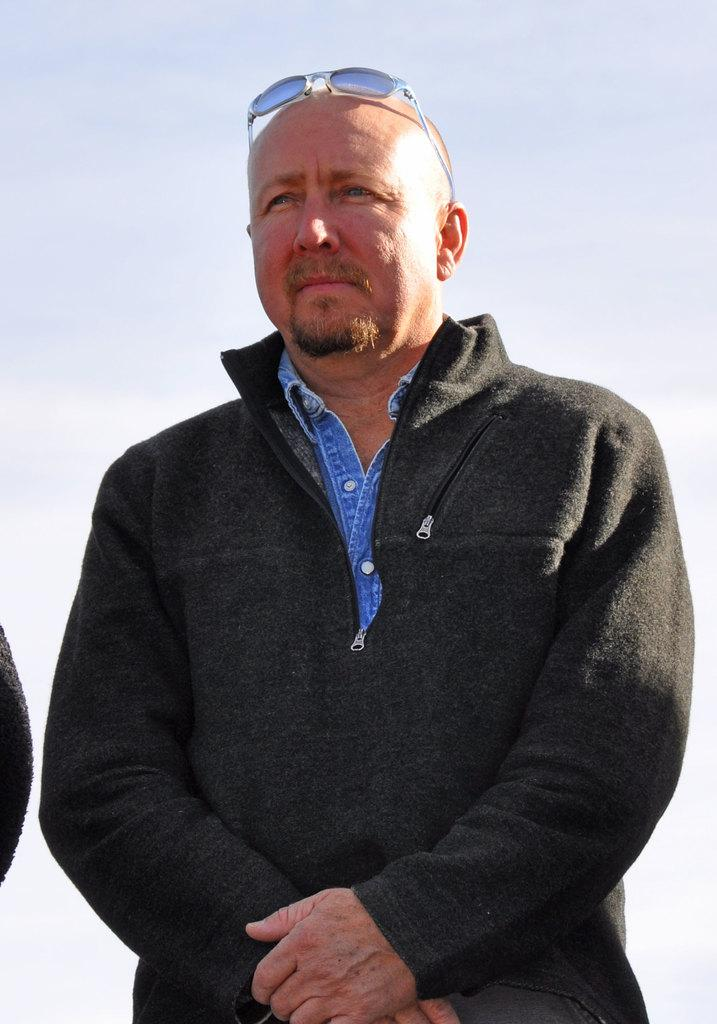What is the main subject of the image? There is a person standing in the center of the image. What is the person wearing in the image? The person is wearing a coat and glasses. Are there any other people in the image? Yes, there is another person in the image. What can be seen in the background of the image? The sky is visible in the background of the image. What type of crime is being committed in the image? There is no indication of a crime being committed in the image. The image features a person standing in the center, wearing a coat and glasses, with another person and the sky visible in the background. 